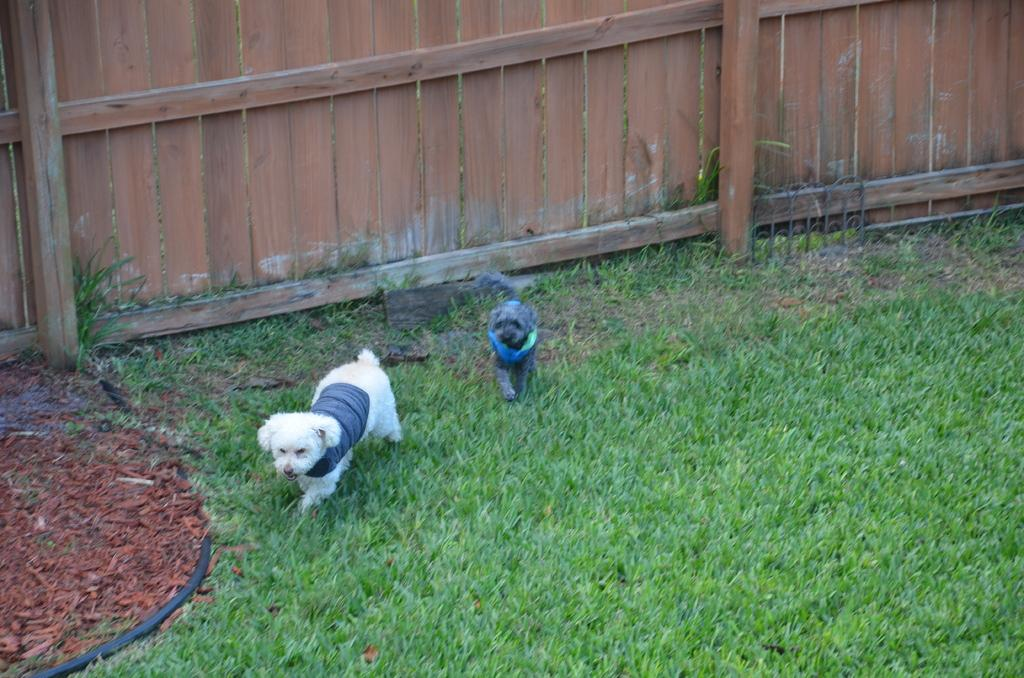What animals are in the center of the image? There are two dogs in the center of the image. What type of surface is visible in the image? There is grass in the image. What color is the object in the image? There is a black color object in the image. What type of fence can be seen in the background of the image? There is a wooden fence in the background of the image. What type of iron form can be seen in the image? There is no iron form present in the image. What rhythm is being played by the dogs in the image? The dogs in the image are not playing any rhythm; they are simply present in the image. 